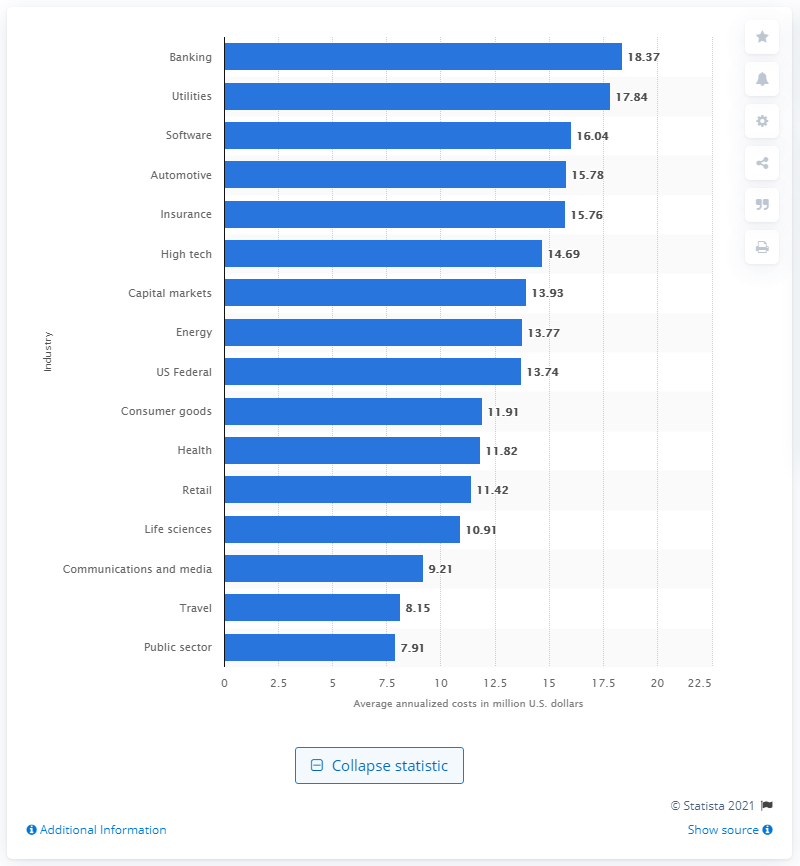Outline some significant characteristics in this image. The average annualized loss for affected companies in the global banking sector was 18.37. 